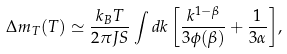<formula> <loc_0><loc_0><loc_500><loc_500>\Delta m _ { T } ( T ) \simeq \frac { k _ { B } T } { 2 \pi J S } \int { d k \left [ \frac { k ^ { 1 - \beta } } { 3 \phi ( \beta ) } + \frac { 1 } { 3 \alpha } \right ] } ,</formula> 